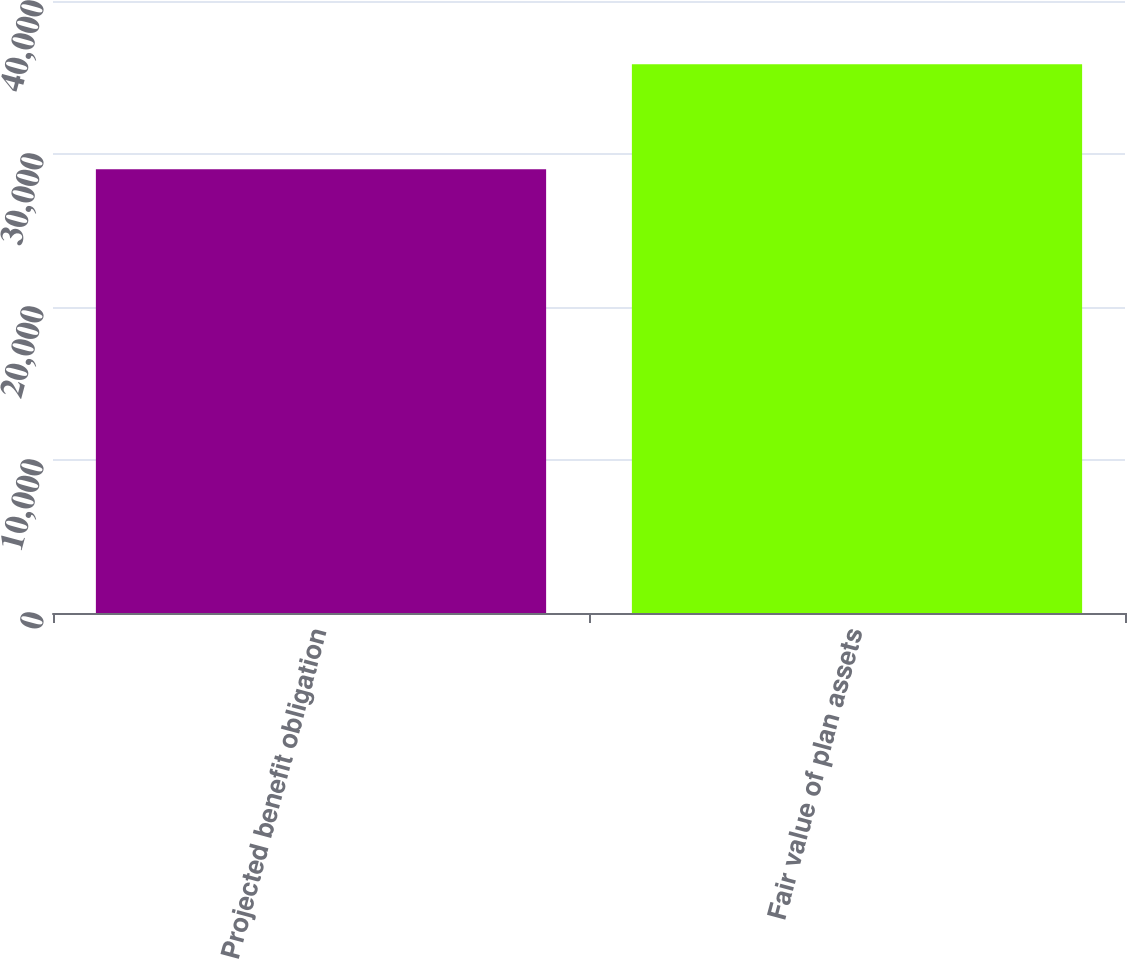Convert chart to OTSL. <chart><loc_0><loc_0><loc_500><loc_500><bar_chart><fcel>Projected benefit obligation<fcel>Fair value of plan assets<nl><fcel>28998<fcel>35859<nl></chart> 